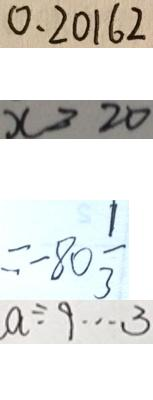Convert formula to latex. <formula><loc_0><loc_0><loc_500><loc_500>0 . 2 0 1 6 2 
 x > 2 0 
 = - 8 0 \frac { 1 } { 3 } 
 a \div 9 \cdots 3</formula> 